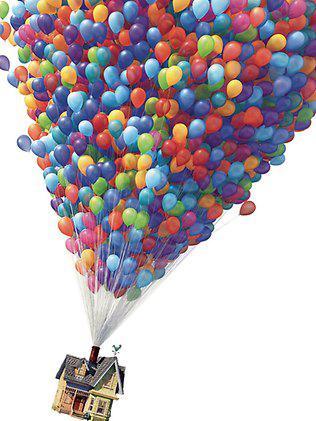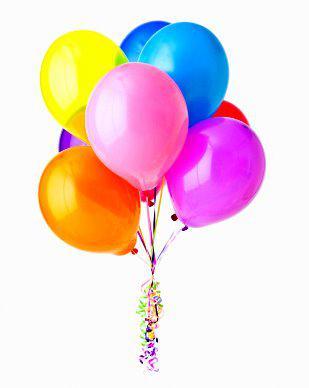The first image is the image on the left, the second image is the image on the right. Analyze the images presented: Is the assertion "Exactly one image shows a mass of balloons in the shape of a hot-air balloon, with their strings coming out of a chimney of a house, and the other image shows a bunch of balloons with no house attached under them." valid? Answer yes or no. Yes. The first image is the image on the left, the second image is the image on the right. Analyze the images presented: Is the assertion "In at least one image there are many ballon made into one big balloon holding a house floating up and right." valid? Answer yes or no. Yes. 